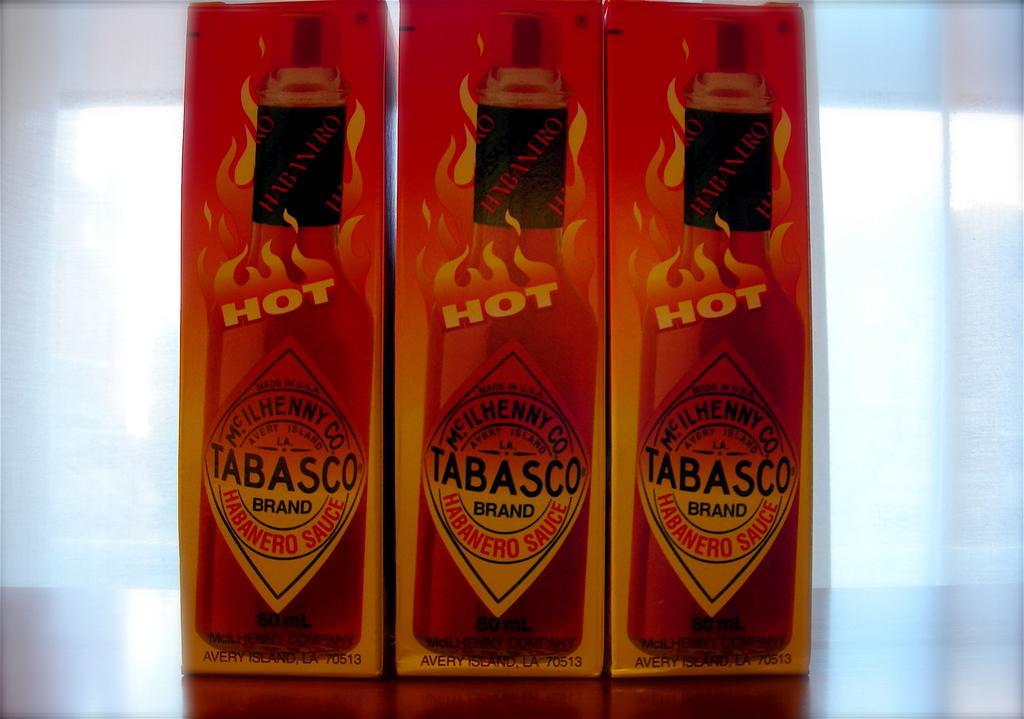Describe this image in one or two sentences. In the foreground of the picture there are three packets on a table. The background is blurred. 